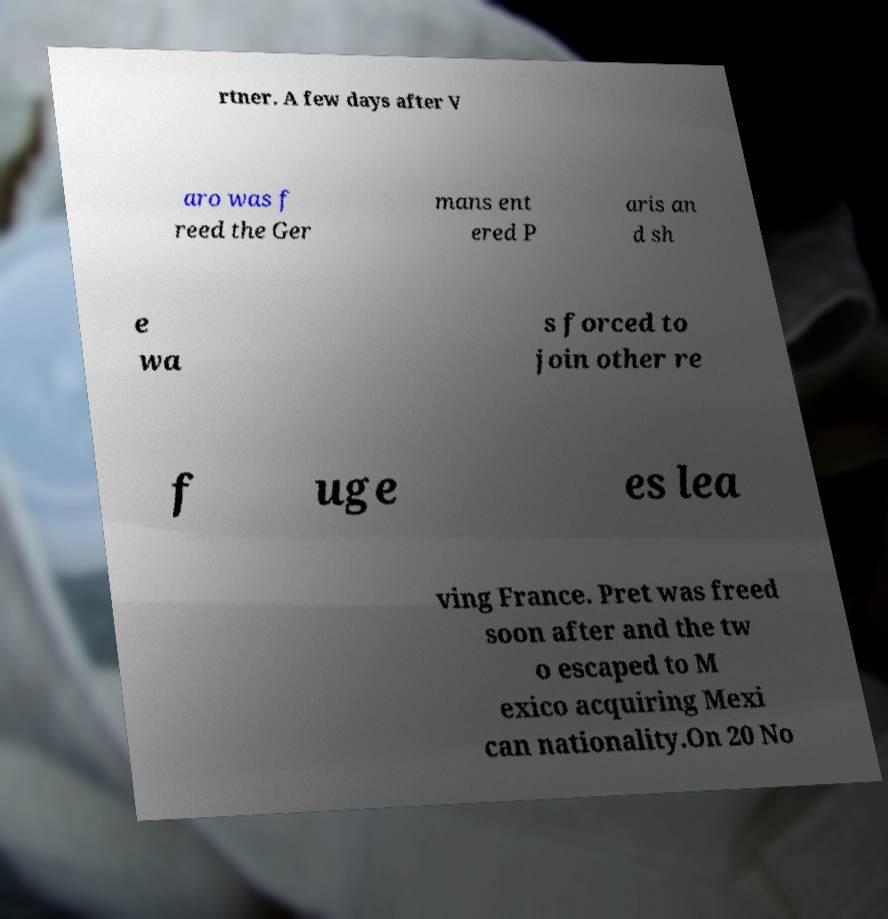What messages or text are displayed in this image? I need them in a readable, typed format. rtner. A few days after V aro was f reed the Ger mans ent ered P aris an d sh e wa s forced to join other re f uge es lea ving France. Pret was freed soon after and the tw o escaped to M exico acquiring Mexi can nationality.On 20 No 